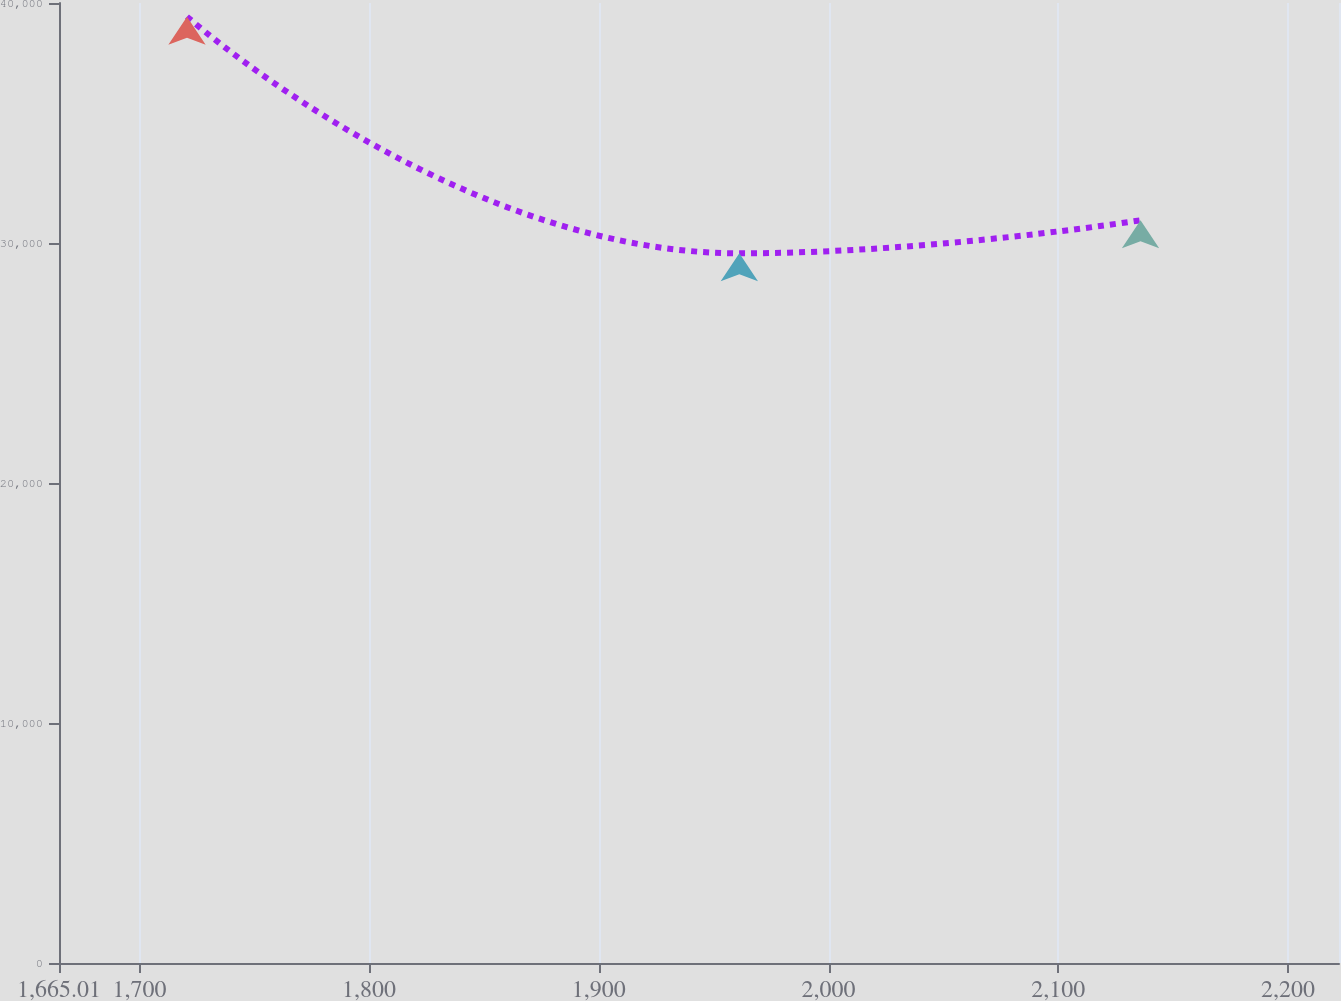<chart> <loc_0><loc_0><loc_500><loc_500><line_chart><ecel><fcel>$ 34,275<nl><fcel>1720.73<fcel>39432.1<nl><fcel>1961.17<fcel>29570.6<nl><fcel>2135.81<fcel>30947.5<nl><fcel>2277.93<fcel>40481.3<nl></chart> 